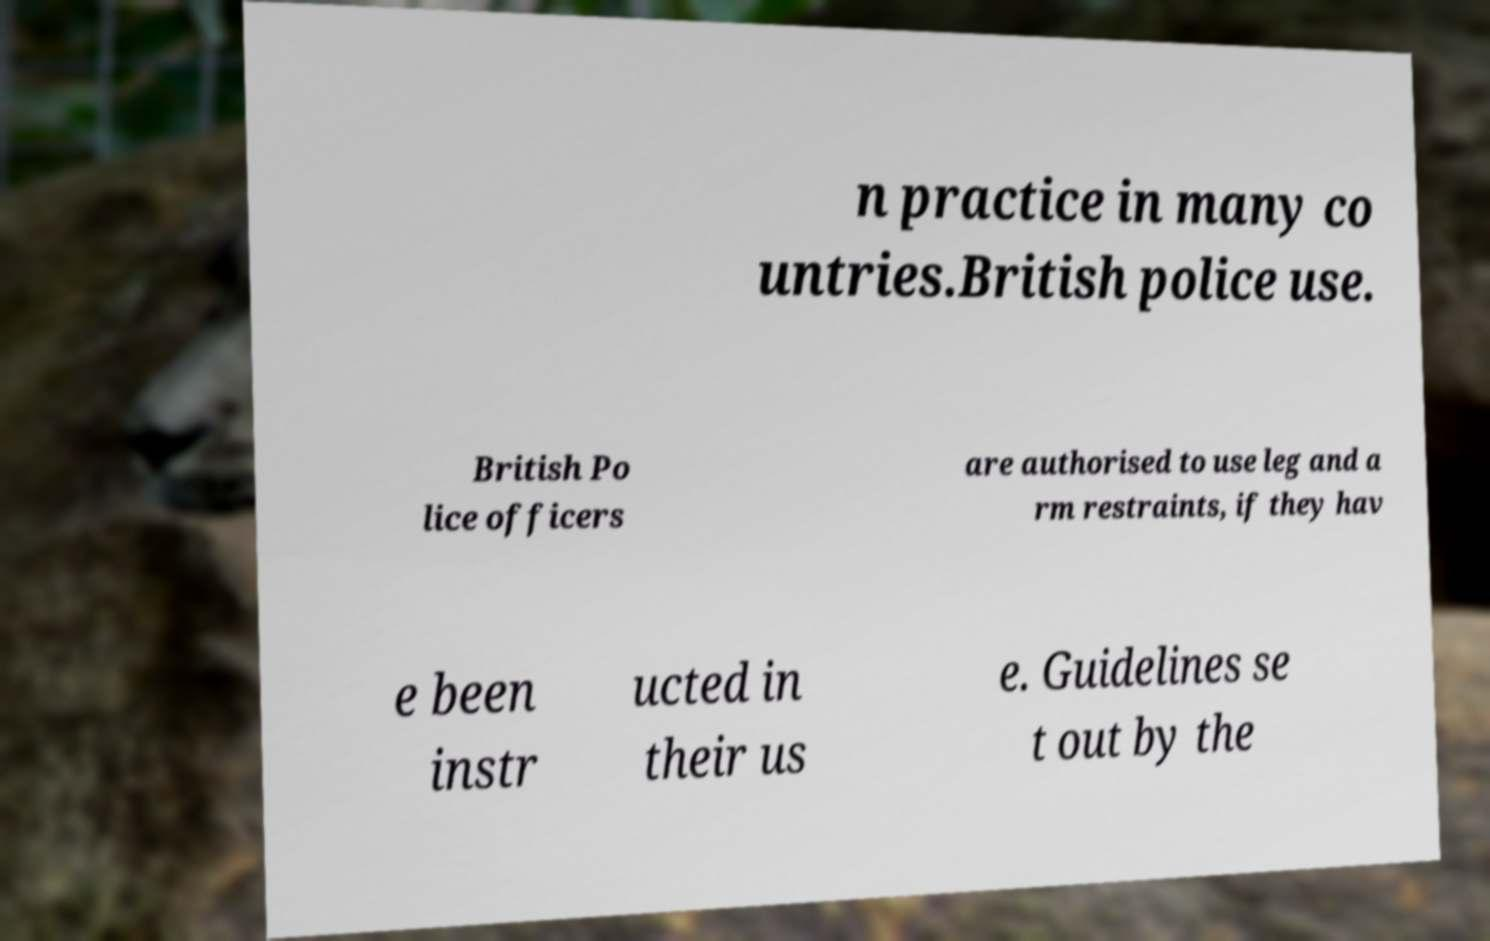What messages or text are displayed in this image? I need them in a readable, typed format. n practice in many co untries.British police use. British Po lice officers are authorised to use leg and a rm restraints, if they hav e been instr ucted in their us e. Guidelines se t out by the 